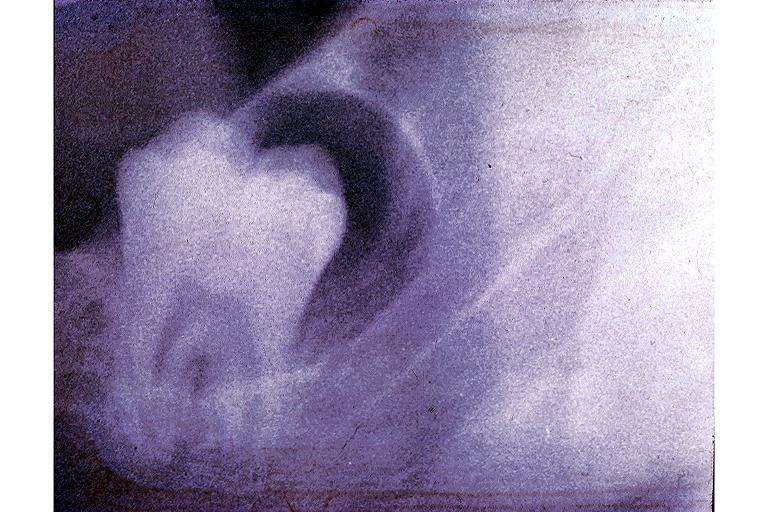s oral present?
Answer the question using a single word or phrase. Yes 